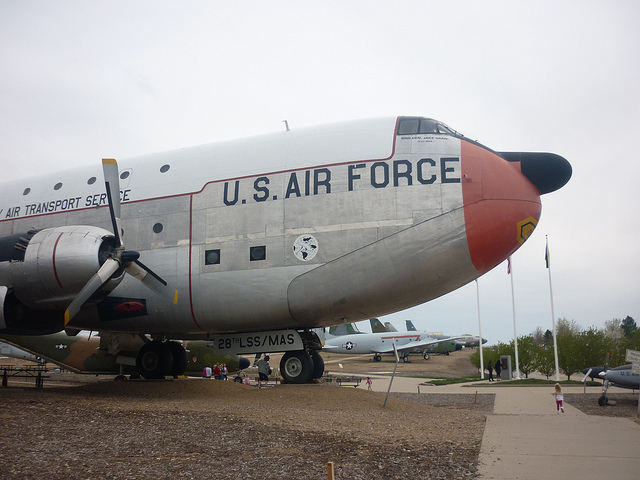Please transcribe the text in this image. U S AIR FORCH SERVICE TRANSPORT AIR MAS LSS 28 